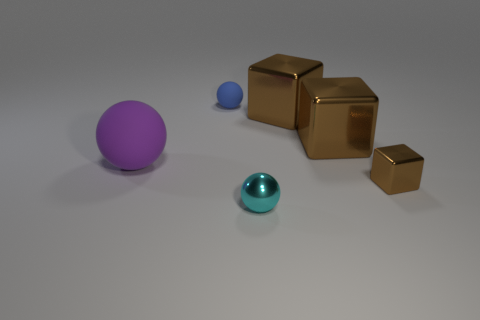Add 1 small cyan things. How many objects exist? 7 Add 2 tiny blue rubber balls. How many tiny blue rubber balls are left? 3 Add 4 gray cylinders. How many gray cylinders exist? 4 Subtract 0 red spheres. How many objects are left? 6 Subtract all small yellow rubber balls. Subtract all tiny spheres. How many objects are left? 4 